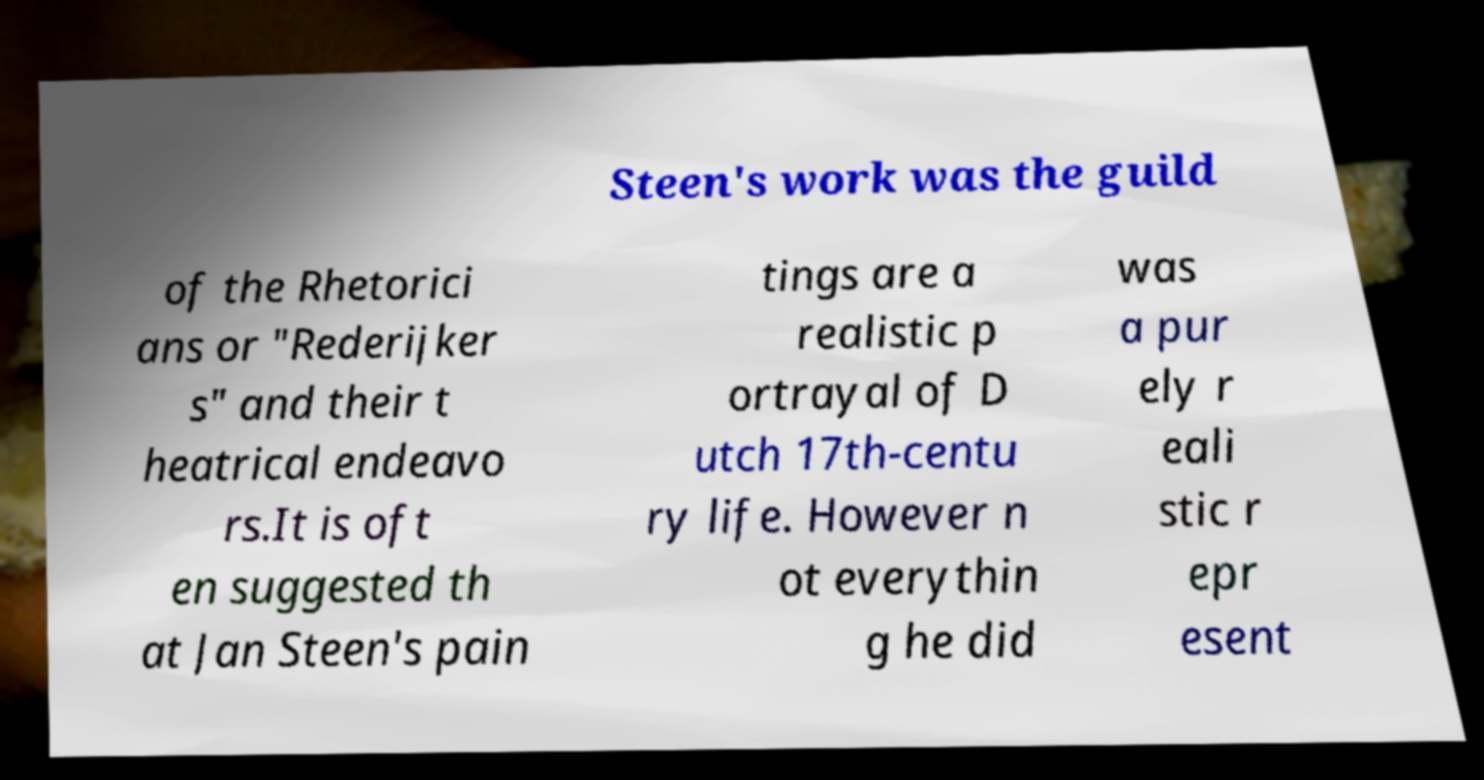Please identify and transcribe the text found in this image. Steen's work was the guild of the Rhetorici ans or "Rederijker s" and their t heatrical endeavo rs.It is oft en suggested th at Jan Steen's pain tings are a realistic p ortrayal of D utch 17th-centu ry life. However n ot everythin g he did was a pur ely r eali stic r epr esent 